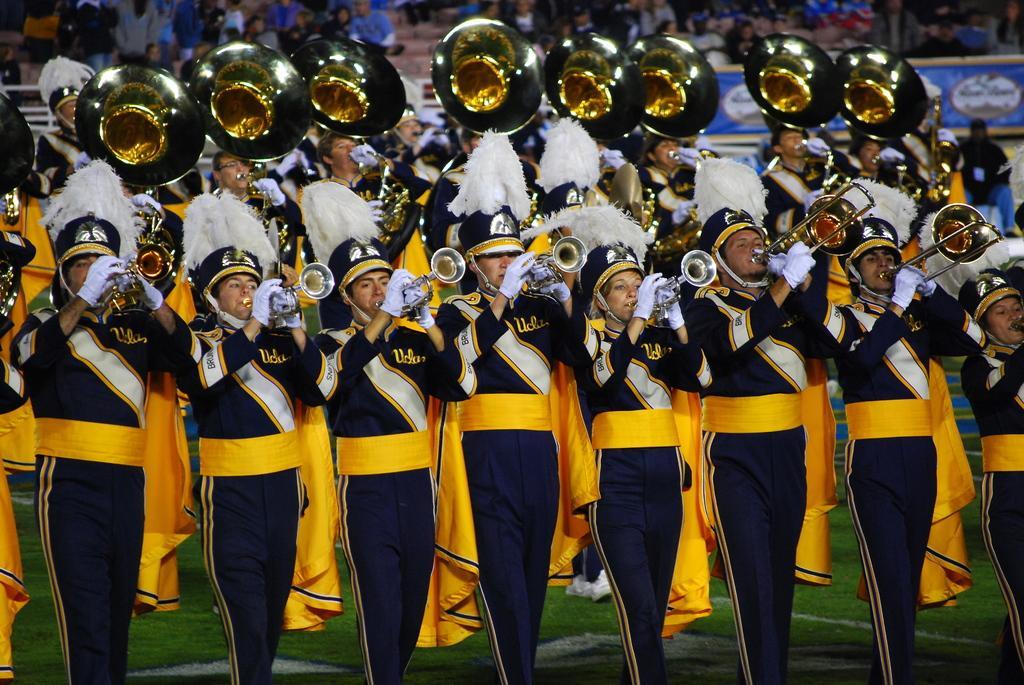Please provide a concise description of this image. In this picture I can see number of people in front and I see that they're wearing same dress and holding musical instruments and they're on the grass. In the background I can see few more people. 